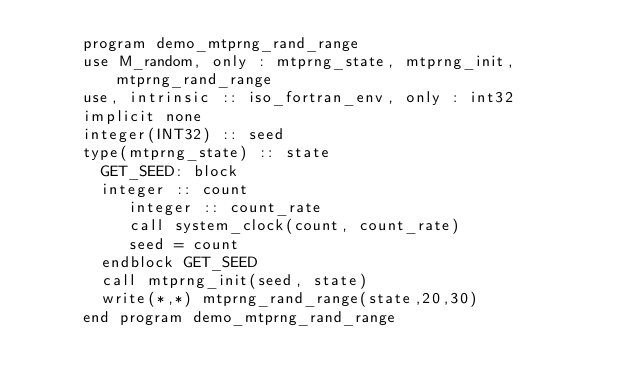<code> <loc_0><loc_0><loc_500><loc_500><_FORTRAN_>     program demo_mtprng_rand_range
     use M_random, only : mtprng_state, mtprng_init, mtprng_rand_range
     use, intrinsic :: iso_fortran_env, only : int32
     implicit none
     integer(INT32) :: seed
     type(mtprng_state) :: state
       GET_SEED: block
       integer :: count
          integer :: count_rate
          call system_clock(count, count_rate)
          seed = count
       endblock GET_SEED
       call mtprng_init(seed, state)
       write(*,*) mtprng_rand_range(state,20,30)
     end program demo_mtprng_rand_range
</code> 